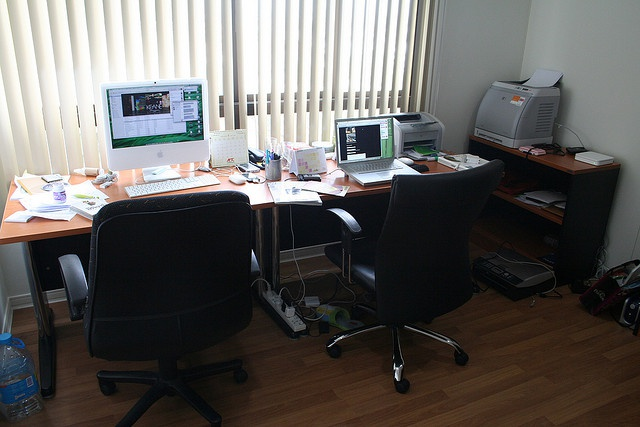Describe the objects in this image and their specific colors. I can see chair in ivory, black, gray, and darkblue tones, chair in ivory, black, gray, and darkgray tones, tv in ivory, lavender, darkgray, and black tones, laptop in ivory, white, black, gray, and darkgray tones, and bottle in ivory, black, navy, blue, and gray tones in this image. 